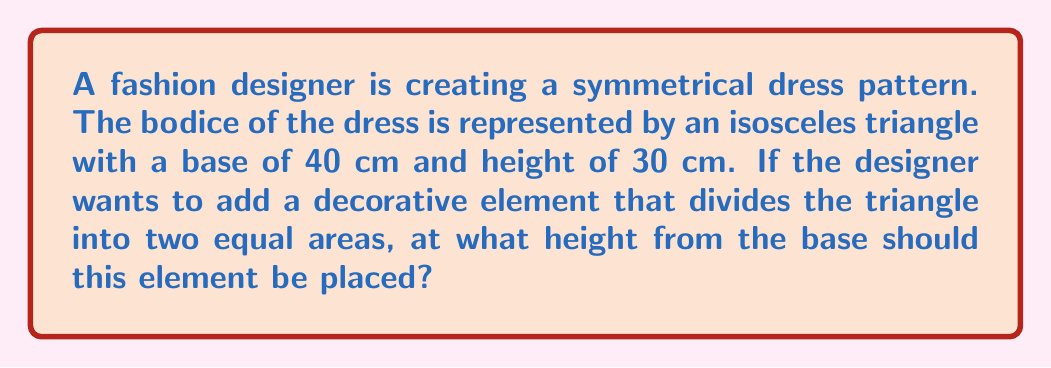Provide a solution to this math problem. Let's approach this step-by-step:

1) First, we need to calculate the area of the entire isosceles triangle:
   Area of triangle = $\frac{1}{2} \times base \times height$
   $A = \frac{1}{2} \times 40 \times 30 = 600$ cm²

2) We want to divide this area into two equal parts, so each part should have an area of:
   $\frac{600}{2} = 300$ cm²

3) Let's call the height at which we need to place the decorative element $h$. This will create a smaller triangle with base 40 cm and height $h$.

4) The area of this smaller triangle should be 300 cm². We can set up an equation:
   $\frac{1}{2} \times 40 \times h = 300$

5) Solving for $h$:
   $20h = 300$
   $h = 15$ cm

6) To verify, let's check if this divides the original triangle into two equal areas:
   Bottom triangle: $\frac{1}{2} \times 40 \times 15 = 300$ cm²
   Top trapezoid: $600 - 300 = 300$ cm²

Therefore, the decorative element should be placed 15 cm from the base of the triangle to achieve perfect balance in the design.
Answer: 15 cm 